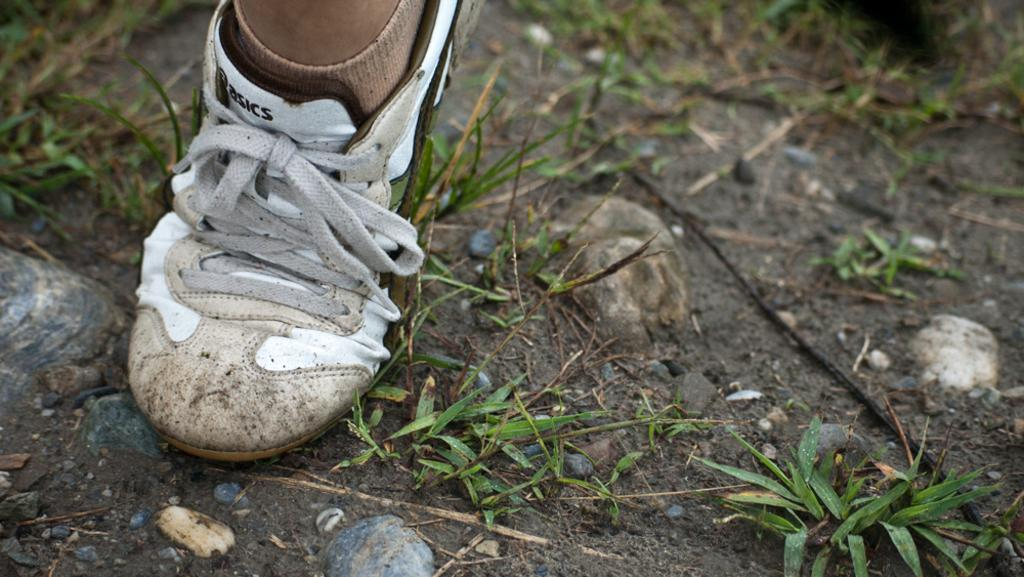What part of a person's body is visible in the image? There is a person's leg in the image. What type of footwear is the person wearing? The leg is wearing a white shoe. Are there any additional clothing items visible on the leg? Yes, the leg is also wearing socks. What type of terrain can be seen in the image? There is grass visible in the image, and there are stones on the ground. What book is the person reading in the image? There is no book or reading activity present in the image; it only shows a person's leg wearing a white shoe and socks, with grass and stones visible in the background. 